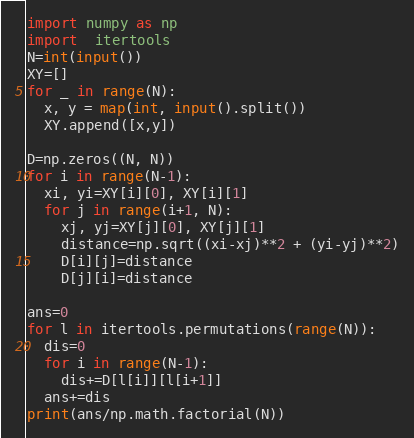<code> <loc_0><loc_0><loc_500><loc_500><_Python_>import numpy as np
import  itertools
N=int(input())
XY=[]
for _ in range(N):
  x, y = map(int, input().split())
  XY.append([x,y])

D=np.zeros((N, N))
for i in range(N-1):
  xi, yi=XY[i][0], XY[i][1]
  for j in range(i+1, N):
    xj, yj=XY[j][0], XY[j][1]
    distance=np.sqrt((xi-xj)**2 + (yi-yj)**2)
    D[i][j]=distance
    D[j][i]=distance

ans=0
for l in itertools.permutations(range(N)):
  dis=0
  for i in range(N-1):
    dis+=D[l[i]][l[i+1]]
  ans+=dis
print(ans/np.math.factorial(N))

</code> 